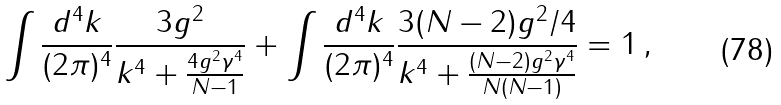Convert formula to latex. <formula><loc_0><loc_0><loc_500><loc_500>\int \frac { d ^ { 4 } k } { ( 2 \pi ) ^ { 4 } } \frac { 3 g ^ { 2 } } { k ^ { 4 } + \frac { 4 g ^ { 2 } \gamma ^ { 4 } } { N - 1 } } + \int \frac { d ^ { 4 } k } { ( 2 \pi ) ^ { 4 } } \frac { 3 ( N - 2 ) g ^ { 2 } / 4 } { k ^ { 4 } + \frac { ( N - 2 ) g ^ { 2 } \gamma ^ { 4 } } { N ( N - 1 ) } } = 1 \, ,</formula> 